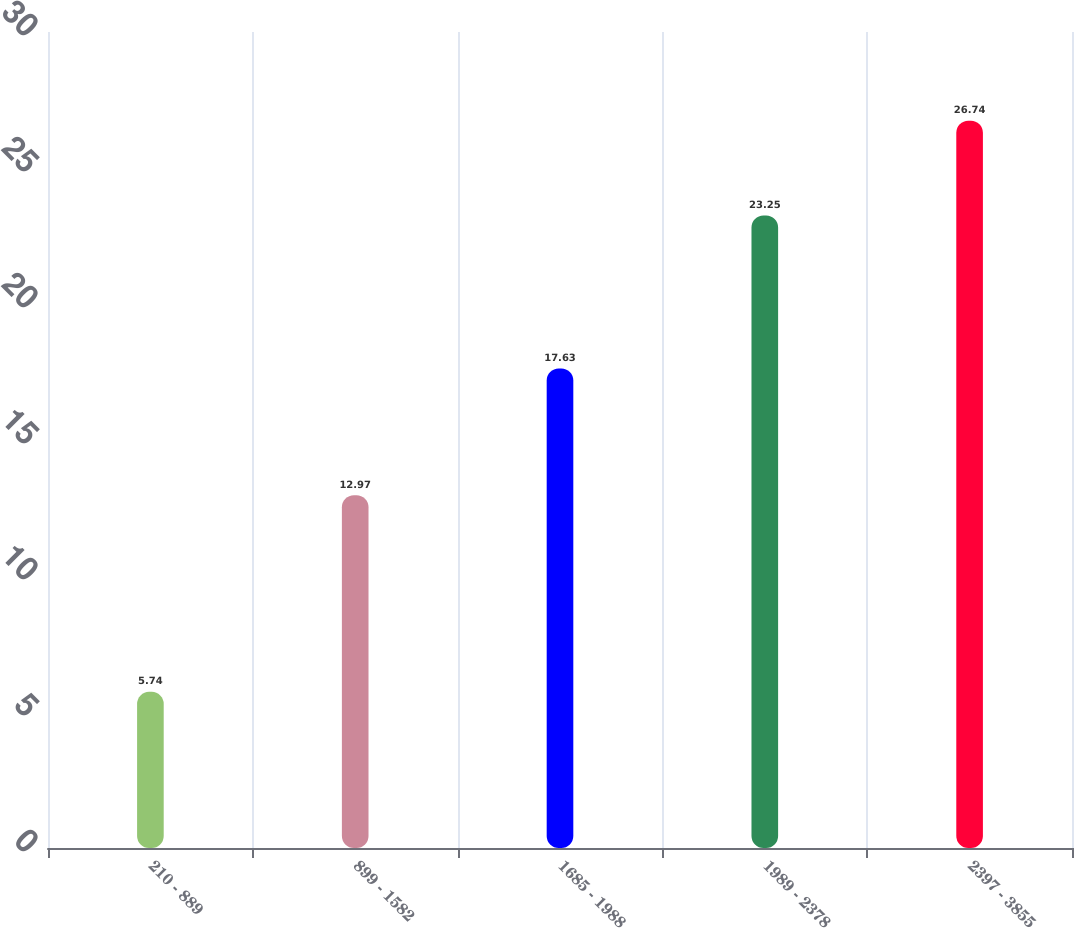Convert chart to OTSL. <chart><loc_0><loc_0><loc_500><loc_500><bar_chart><fcel>210 - 889<fcel>899 - 1582<fcel>1685 - 1988<fcel>1989 - 2378<fcel>2397 - 3855<nl><fcel>5.74<fcel>12.97<fcel>17.63<fcel>23.25<fcel>26.74<nl></chart> 